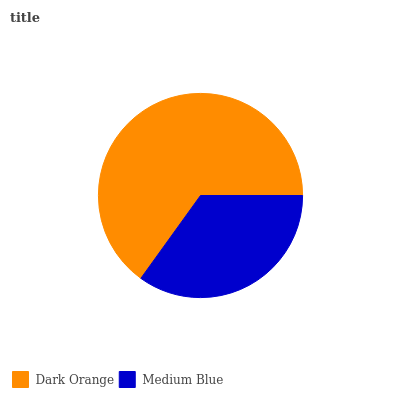Is Medium Blue the minimum?
Answer yes or no. Yes. Is Dark Orange the maximum?
Answer yes or no. Yes. Is Medium Blue the maximum?
Answer yes or no. No. Is Dark Orange greater than Medium Blue?
Answer yes or no. Yes. Is Medium Blue less than Dark Orange?
Answer yes or no. Yes. Is Medium Blue greater than Dark Orange?
Answer yes or no. No. Is Dark Orange less than Medium Blue?
Answer yes or no. No. Is Dark Orange the high median?
Answer yes or no. Yes. Is Medium Blue the low median?
Answer yes or no. Yes. Is Medium Blue the high median?
Answer yes or no. No. Is Dark Orange the low median?
Answer yes or no. No. 